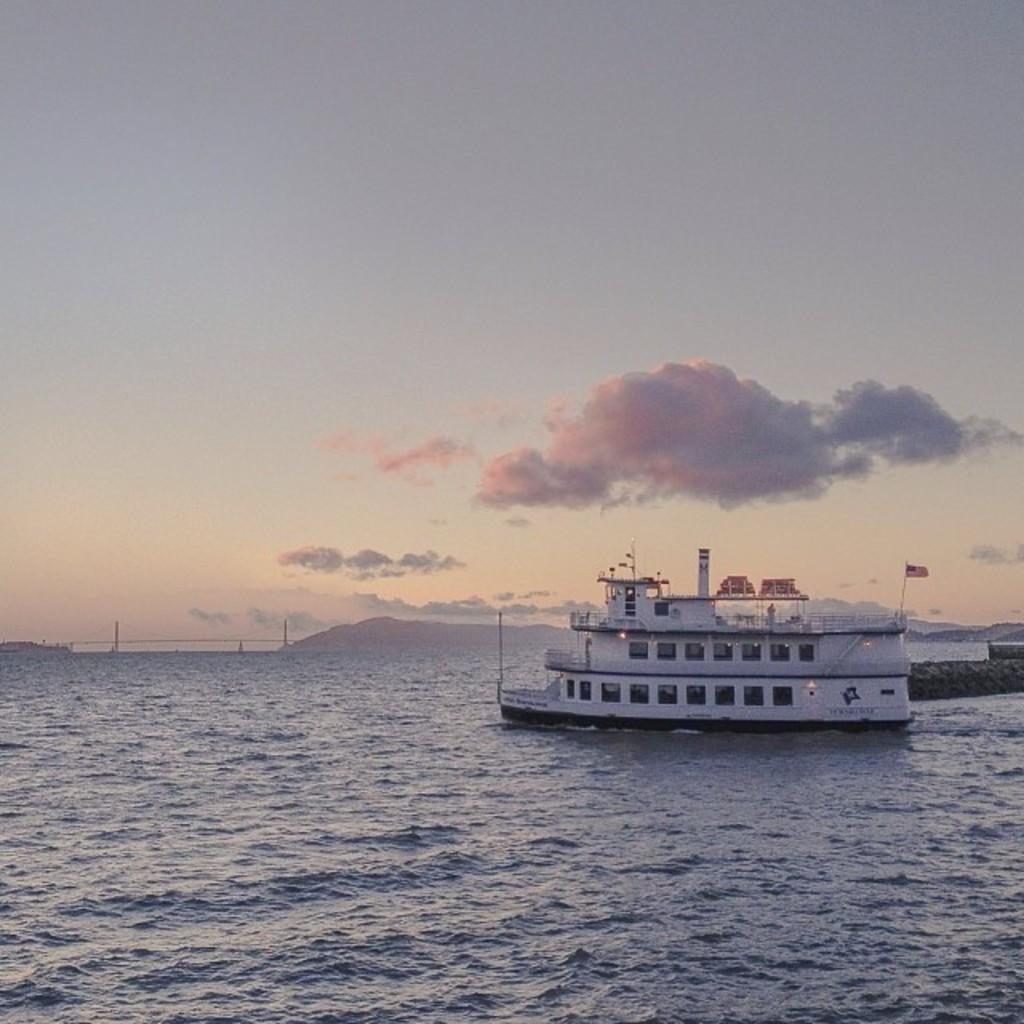What is the main subject of the image? The main subject of the image is a ship. Where is the ship located? The ship is on the water. What can be seen flying on the ship? There is a flag in the image. What structures are present on the ship? There are poles in the image. What else can be seen in the image besides the ship and its features? There are some objects in the image. What is visible in the background of the image? The sky is visible in the background of the image, and clouds are present in the sky. How much sand can be seen on the ship in the image? There is no sand present in the image; it features a ship on the water with a flag and poles. 